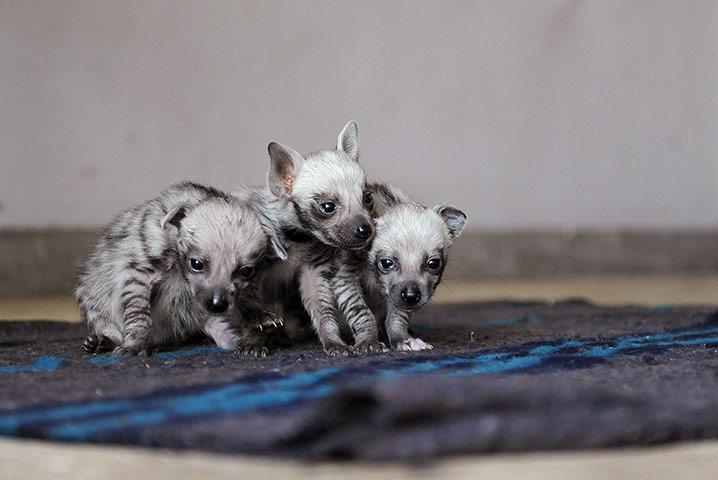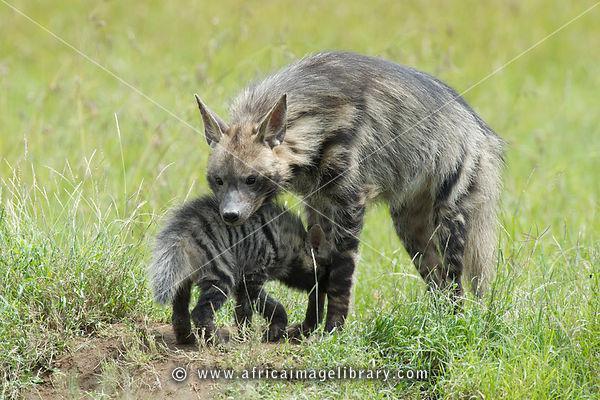The first image is the image on the left, the second image is the image on the right. Examine the images to the left and right. Is the description "The right image contains at least two hyenas." accurate? Answer yes or no. Yes. The first image is the image on the left, the second image is the image on the right. Examine the images to the left and right. Is the description "In the left image, we have a mother and her pups." accurate? Answer yes or no. No. 